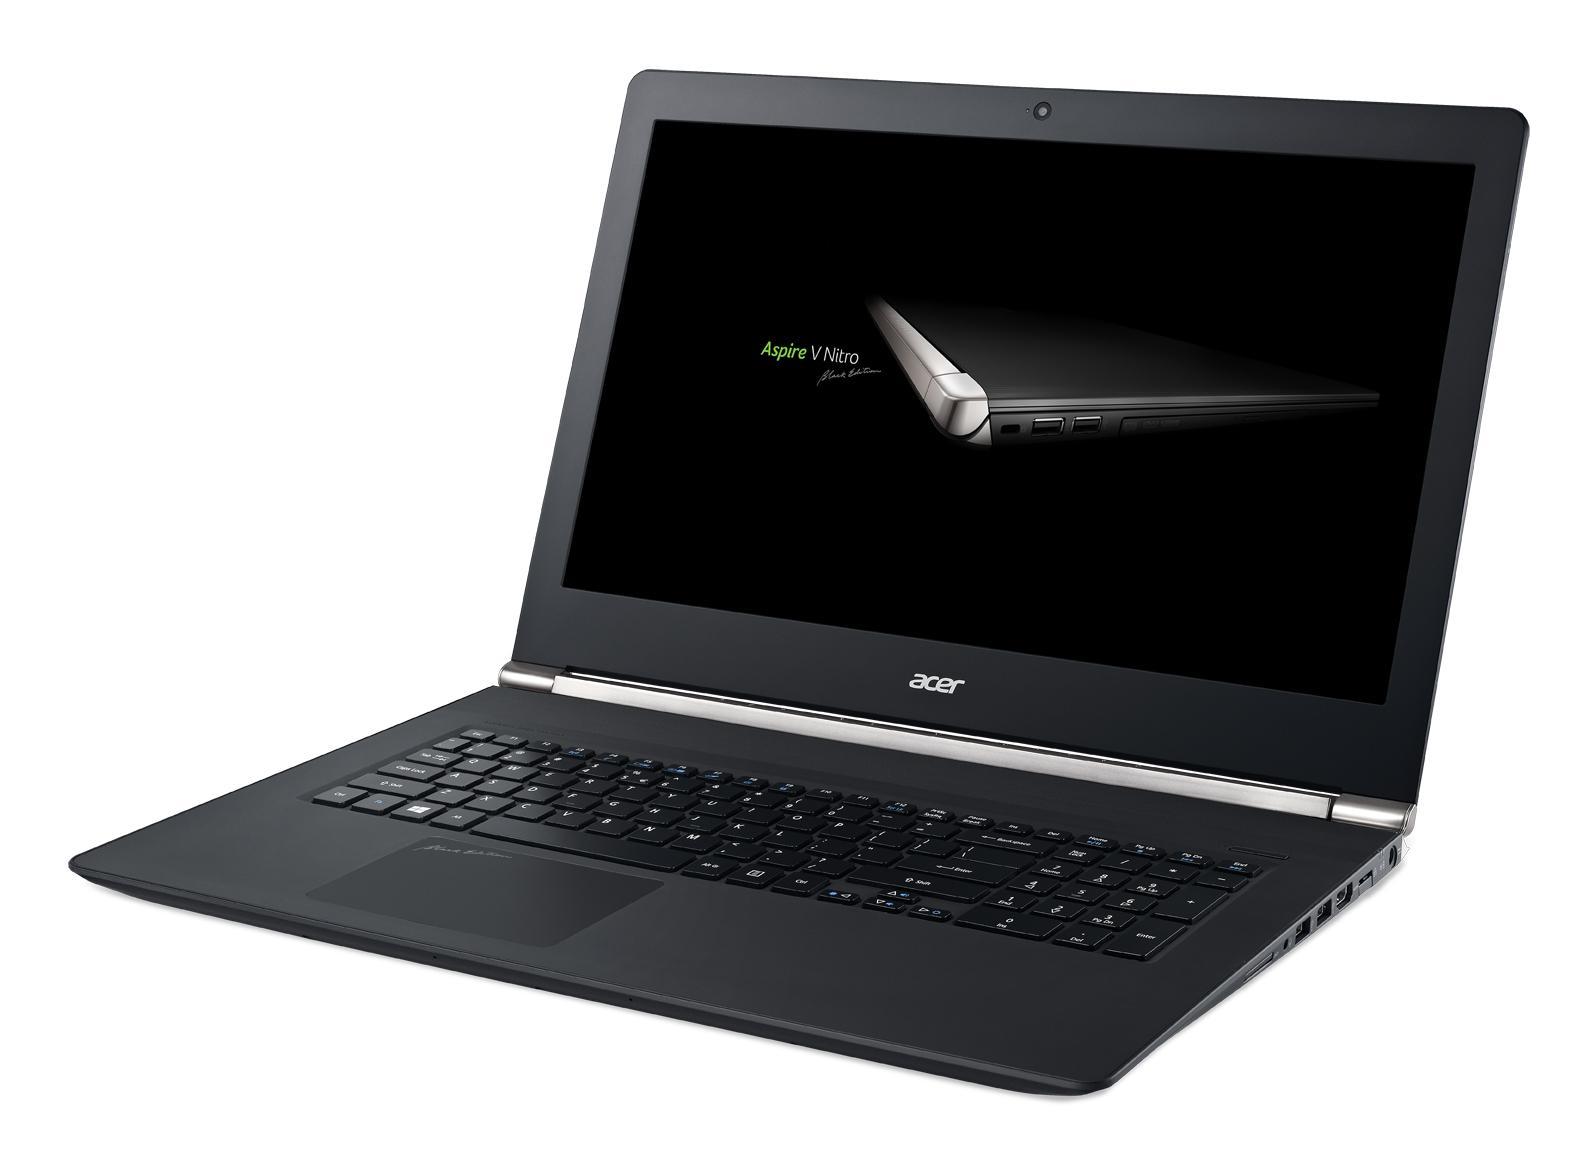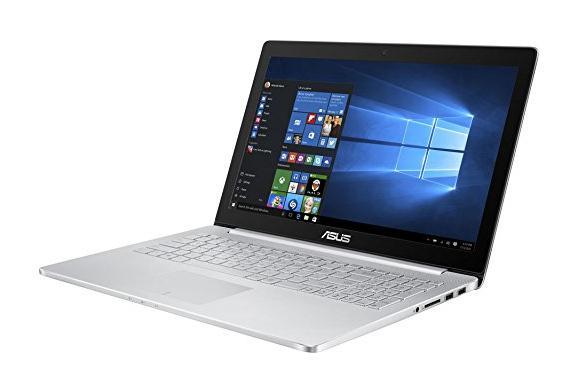The first image is the image on the left, the second image is the image on the right. Considering the images on both sides, is "In at least one image there is an open laptop with a blue background, thats bottom is silver and frame around the screen is black." valid? Answer yes or no. Yes. The first image is the image on the left, the second image is the image on the right. Assess this claim about the two images: "The left image contains one leftward-facing open laptop with a mostly black screen, and the right image contains one leftward-facing laptop with a mostly blue screen.". Correct or not? Answer yes or no. Yes. 